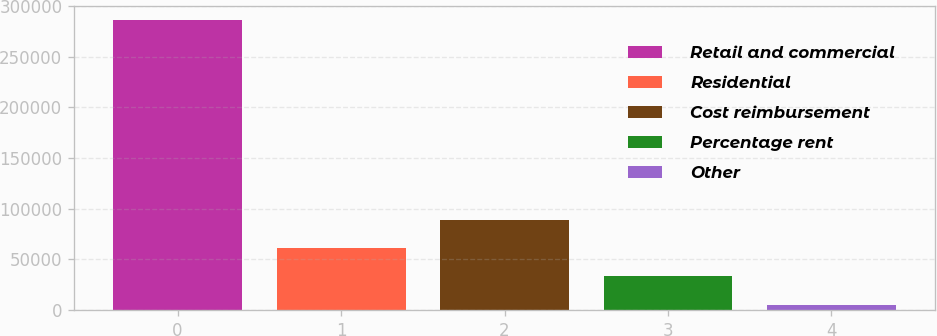<chart> <loc_0><loc_0><loc_500><loc_500><bar_chart><fcel>Retail and commercial<fcel>Residential<fcel>Cost reimbursement<fcel>Percentage rent<fcel>Other<nl><fcel>285764<fcel>61375.2<fcel>89423.8<fcel>33326.6<fcel>5278<nl></chart> 